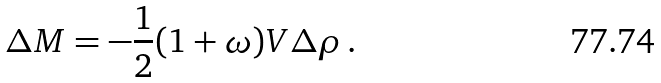<formula> <loc_0><loc_0><loc_500><loc_500>\Delta M = - \frac { 1 } { 2 } ( 1 + \omega ) V \Delta \rho \, .</formula> 